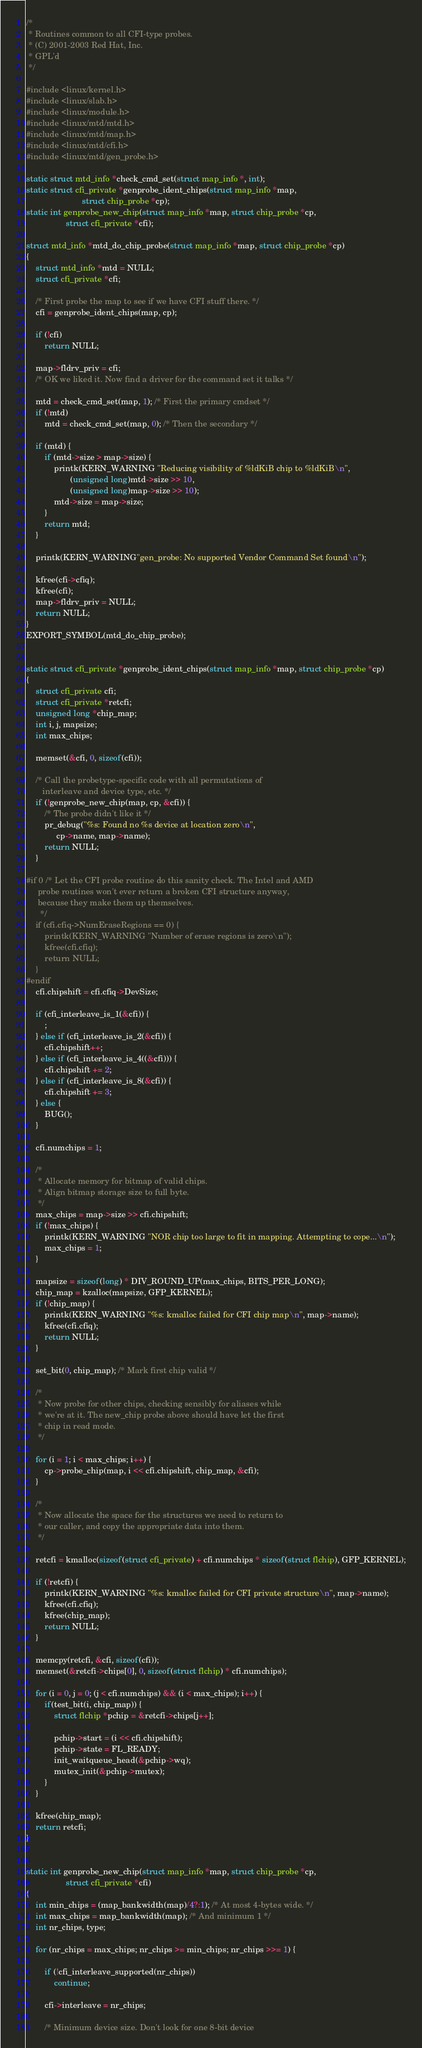<code> <loc_0><loc_0><loc_500><loc_500><_C_>/*
 * Routines common to all CFI-type probes.
 * (C) 2001-2003 Red Hat, Inc.
 * GPL'd
 */

#include <linux/kernel.h>
#include <linux/slab.h>
#include <linux/module.h>
#include <linux/mtd/mtd.h>
#include <linux/mtd/map.h>
#include <linux/mtd/cfi.h>
#include <linux/mtd/gen_probe.h>

static struct mtd_info *check_cmd_set(struct map_info *, int);
static struct cfi_private *genprobe_ident_chips(struct map_info *map,
						struct chip_probe *cp);
static int genprobe_new_chip(struct map_info *map, struct chip_probe *cp,
			     struct cfi_private *cfi);

struct mtd_info *mtd_do_chip_probe(struct map_info *map, struct chip_probe *cp)
{
	struct mtd_info *mtd = NULL;
	struct cfi_private *cfi;

	/* First probe the map to see if we have CFI stuff there. */
	cfi = genprobe_ident_chips(map, cp);

	if (!cfi)
		return NULL;

	map->fldrv_priv = cfi;
	/* OK we liked it. Now find a driver for the command set it talks */

	mtd = check_cmd_set(map, 1); /* First the primary cmdset */
	if (!mtd)
		mtd = check_cmd_set(map, 0); /* Then the secondary */

	if (mtd) {
		if (mtd->size > map->size) {
			printk(KERN_WARNING "Reducing visibility of %ldKiB chip to %ldKiB\n",
			       (unsigned long)mtd->size >> 10,
			       (unsigned long)map->size >> 10);
			mtd->size = map->size;
		}
		return mtd;
	}

	printk(KERN_WARNING"gen_probe: No supported Vendor Command Set found\n");

	kfree(cfi->cfiq);
	kfree(cfi);
	map->fldrv_priv = NULL;
	return NULL;
}
EXPORT_SYMBOL(mtd_do_chip_probe);


static struct cfi_private *genprobe_ident_chips(struct map_info *map, struct chip_probe *cp)
{
	struct cfi_private cfi;
	struct cfi_private *retcfi;
	unsigned long *chip_map;
	int i, j, mapsize;
	int max_chips;

	memset(&cfi, 0, sizeof(cfi));

	/* Call the probetype-specific code with all permutations of
	   interleave and device type, etc. */
	if (!genprobe_new_chip(map, cp, &cfi)) {
		/* The probe didn't like it */
		pr_debug("%s: Found no %s device at location zero\n",
			 cp->name, map->name);
		return NULL;
	}

#if 0 /* Let the CFI probe routine do this sanity check. The Intel and AMD
	 probe routines won't ever return a broken CFI structure anyway,
	 because they make them up themselves.
      */
	if (cfi.cfiq->NumEraseRegions == 0) {
		printk(KERN_WARNING "Number of erase regions is zero\n");
		kfree(cfi.cfiq);
		return NULL;
	}
#endif
	cfi.chipshift = cfi.cfiq->DevSize;

	if (cfi_interleave_is_1(&cfi)) {
		;
	} else if (cfi_interleave_is_2(&cfi)) {
		cfi.chipshift++;
	} else if (cfi_interleave_is_4((&cfi))) {
		cfi.chipshift += 2;
	} else if (cfi_interleave_is_8(&cfi)) {
		cfi.chipshift += 3;
	} else {
		BUG();
	}

	cfi.numchips = 1;

	/*
	 * Allocate memory for bitmap of valid chips.
	 * Align bitmap storage size to full byte.
	 */
	max_chips = map->size >> cfi.chipshift;
	if (!max_chips) {
		printk(KERN_WARNING "NOR chip too large to fit in mapping. Attempting to cope...\n");
		max_chips = 1;
	}

	mapsize = sizeof(long) * DIV_ROUND_UP(max_chips, BITS_PER_LONG);
	chip_map = kzalloc(mapsize, GFP_KERNEL);
	if (!chip_map) {
		printk(KERN_WARNING "%s: kmalloc failed for CFI chip map\n", map->name);
		kfree(cfi.cfiq);
		return NULL;
	}

	set_bit(0, chip_map); /* Mark first chip valid */

	/*
	 * Now probe for other chips, checking sensibly for aliases while
	 * we're at it. The new_chip probe above should have let the first
	 * chip in read mode.
	 */

	for (i = 1; i < max_chips; i++) {
		cp->probe_chip(map, i << cfi.chipshift, chip_map, &cfi);
	}

	/*
	 * Now allocate the space for the structures we need to return to
	 * our caller, and copy the appropriate data into them.
	 */

	retcfi = kmalloc(sizeof(struct cfi_private) + cfi.numchips * sizeof(struct flchip), GFP_KERNEL);

	if (!retcfi) {
		printk(KERN_WARNING "%s: kmalloc failed for CFI private structure\n", map->name);
		kfree(cfi.cfiq);
		kfree(chip_map);
		return NULL;
	}

	memcpy(retcfi, &cfi, sizeof(cfi));
	memset(&retcfi->chips[0], 0, sizeof(struct flchip) * cfi.numchips);

	for (i = 0, j = 0; (j < cfi.numchips) && (i < max_chips); i++) {
		if(test_bit(i, chip_map)) {
			struct flchip *pchip = &retcfi->chips[j++];

			pchip->start = (i << cfi.chipshift);
			pchip->state = FL_READY;
			init_waitqueue_head(&pchip->wq);
			mutex_init(&pchip->mutex);
		}
	}

	kfree(chip_map);
	return retcfi;
}


static int genprobe_new_chip(struct map_info *map, struct chip_probe *cp,
			     struct cfi_private *cfi)
{
	int min_chips = (map_bankwidth(map)/4?:1); /* At most 4-bytes wide. */
	int max_chips = map_bankwidth(map); /* And minimum 1 */
	int nr_chips, type;

	for (nr_chips = max_chips; nr_chips >= min_chips; nr_chips >>= 1) {

		if (!cfi_interleave_supported(nr_chips))
		    continue;

		cfi->interleave = nr_chips;

		/* Minimum device size. Don't look for one 8-bit device</code> 